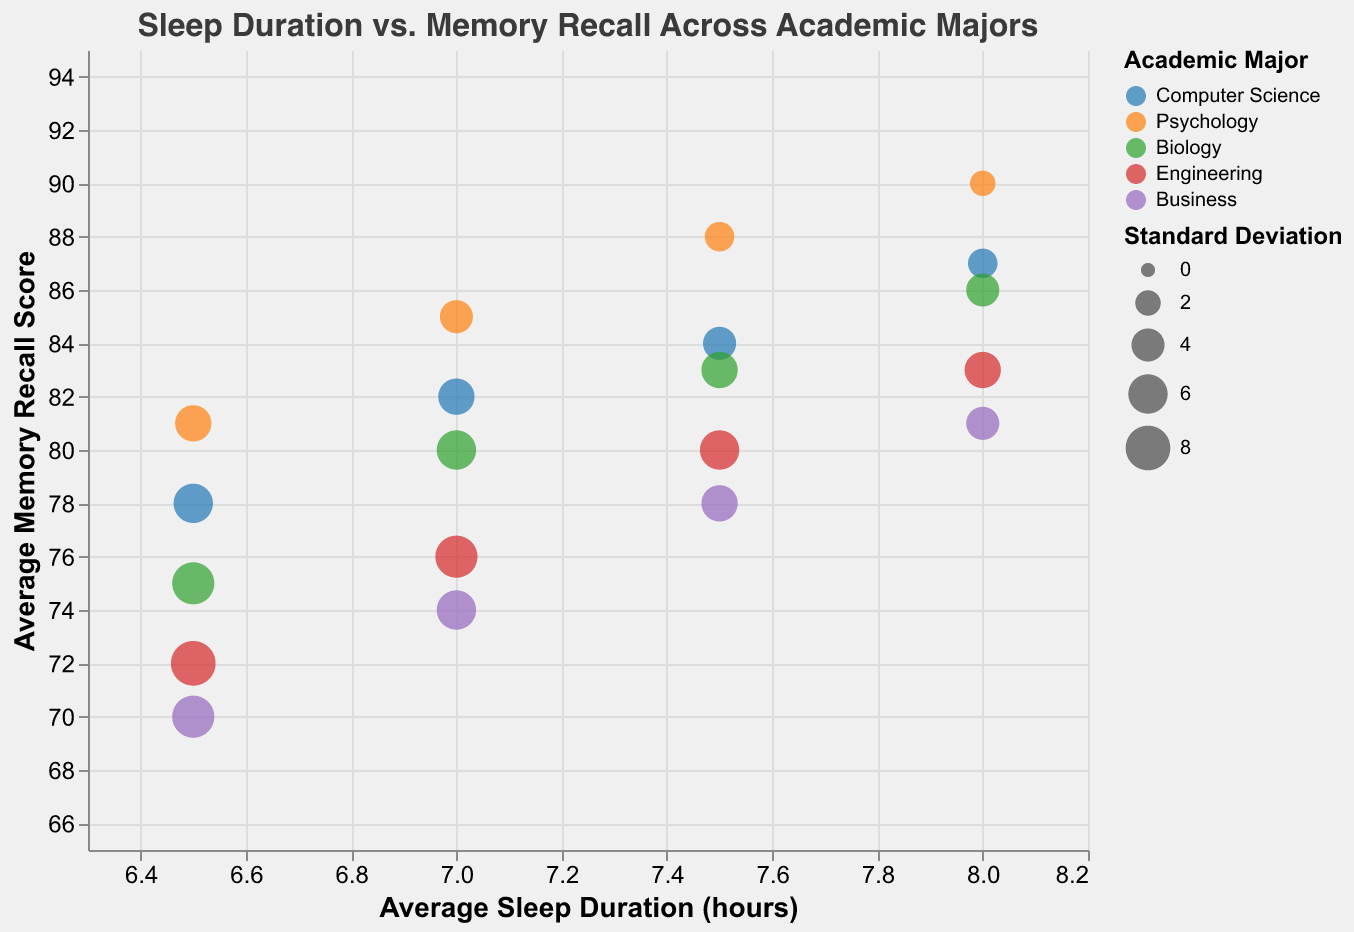What is the title of the chart? The title is located at the top of the chart and reads "Sleep Duration vs. Memory Recall Across Academic Majors".
Answer: Sleep Duration vs. Memory Recall Across Academic Majors How many academic majors are represented in the chart? By observing the different colors and the legend, we can see that there are 5 academic majors represented in the chart.
Answer: 5 Which major has the highest average memory recall score for 8 hours of sleep? By looking at the data points corresponding to 8 hours of sleep on the X-axis, we can see that Psychology has the highest average memory recall score of 90.
Answer: Psychology What is the average sleep duration for the major with the smallest standard deviation of recall score? The smallest standard deviation of recall score is 2, for Psychology. Looking at the data point, the average sleep duration is 8 hours.
Answer: 8 hours Compare the average memory recall scores for Computer Science and Business for an average sleep duration of 6.5 hours. Which is higher and by how much? For 6.5 hours, Computer Science has an average memory recall score of 78, and Business has 70. The difference is 78 - 70 = 8.
Answer: Computer Science, by 8 What are the standard deviations of recall scores for the Engineering major across different sleep durations? Observing the sizes of the bubbles for Engineering across different sleep durations (6.5, 7, 7.5, 8), the standard deviations are 8, 7, 6, and 5 respectively.
Answer: 8, 7, 6, 5 Which major has the least variability in memory recall scores for an average sleep duration of 7.5 hours? By comparing the sizes of bubbles at 7.5 hours of sleep, we see that Psychology has the smallest bubble size indicating the least variability.
Answer: Psychology What is the range of average memory recall scores for Computer Science across all sleep durations? The average memory recall scores for Computer Science are 78, 82, 84, and 87. The range is the difference between the highest and lowest values, 87 - 78 = 9.
Answer: 9 For a sleep duration of 7 hours, which major shows the highest standard deviation in recall scores? By observing the bubble sizes at 7 hours of sleep, Engineering shows the highest standard deviation with the largest bubble.
Answer: Engineering 